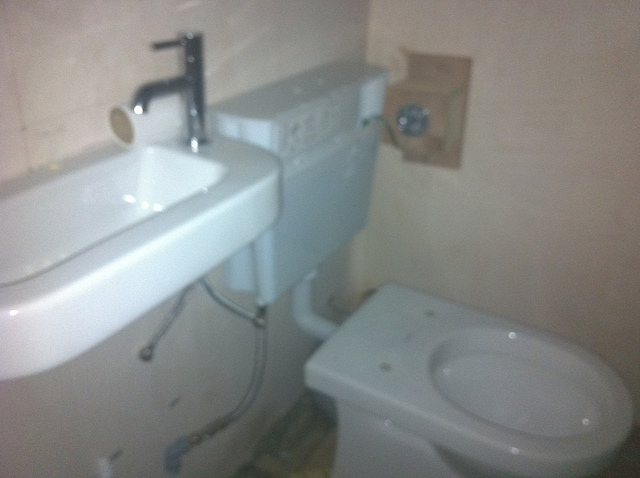Is this bathroom clean? Yes, the bathroom seems to be clean, with no visible dirt or debris on the fixtures. 